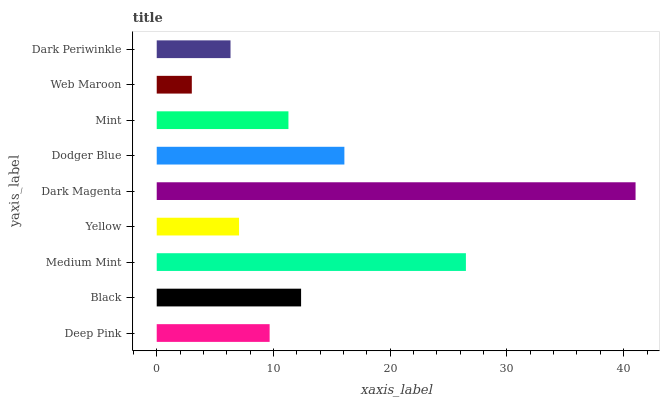Is Web Maroon the minimum?
Answer yes or no. Yes. Is Dark Magenta the maximum?
Answer yes or no. Yes. Is Black the minimum?
Answer yes or no. No. Is Black the maximum?
Answer yes or no. No. Is Black greater than Deep Pink?
Answer yes or no. Yes. Is Deep Pink less than Black?
Answer yes or no. Yes. Is Deep Pink greater than Black?
Answer yes or no. No. Is Black less than Deep Pink?
Answer yes or no. No. Is Mint the high median?
Answer yes or no. Yes. Is Mint the low median?
Answer yes or no. Yes. Is Web Maroon the high median?
Answer yes or no. No. Is Yellow the low median?
Answer yes or no. No. 